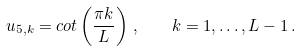Convert formula to latex. <formula><loc_0><loc_0><loc_500><loc_500>u _ { 5 , k } = c o t \left ( \frac { \pi k } { L } \right ) \, , \quad k = 1 , \dots , L - 1 \, .</formula> 